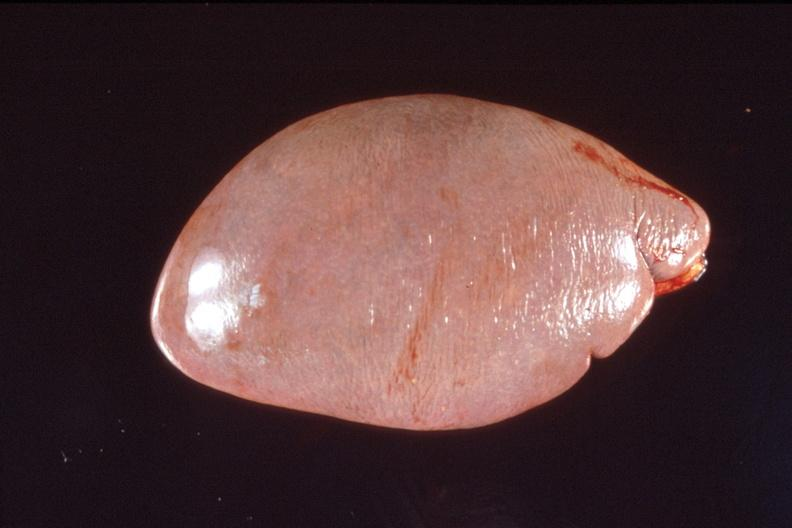does this image show spleen, normal spleen?
Answer the question using a single word or phrase. Yes 